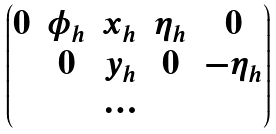<formula> <loc_0><loc_0><loc_500><loc_500>\begin{pmatrix} 0 & \phi _ { h } & x _ { h } & \eta _ { h } & 0 \\ & 0 & y _ { h } & 0 & - \eta _ { h } \\ & & \dots \\ \end{pmatrix}</formula> 